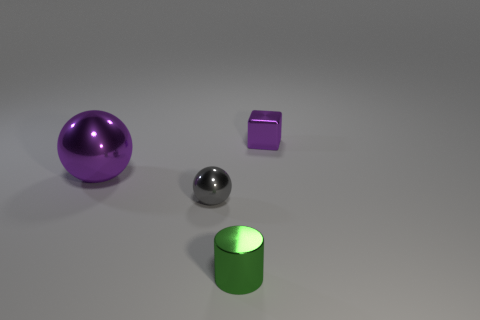Subtract all gray spheres. How many spheres are left? 1 Subtract all cubes. How many objects are left? 3 Subtract all blue blocks. Subtract all gray cylinders. How many blocks are left? 1 Subtract all yellow cylinders. How many blue blocks are left? 0 Subtract all big yellow things. Subtract all green things. How many objects are left? 3 Add 4 gray things. How many gray things are left? 5 Add 4 yellow metallic things. How many yellow metallic things exist? 4 Add 1 small yellow metal things. How many objects exist? 5 Subtract 0 purple cylinders. How many objects are left? 4 Subtract 1 cylinders. How many cylinders are left? 0 